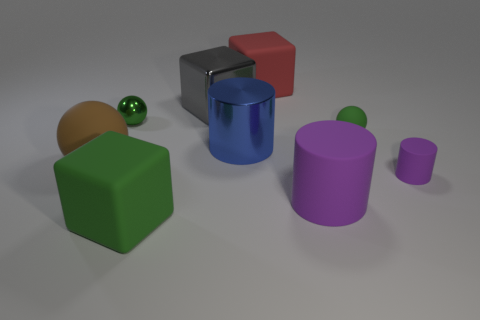There is a brown object that is made of the same material as the large purple thing; what size is it?
Provide a succinct answer. Large. Do the matte sphere that is left of the gray object and the small purple rubber object have the same size?
Offer a terse response. No. Are there more large blocks in front of the large brown rubber object than big cyan objects?
Ensure brevity in your answer.  Yes. Are the large sphere and the green cube made of the same material?
Your answer should be very brief. Yes. What number of objects are cubes in front of the small metallic thing or brown things?
Give a very brief answer. 2. How many other objects are there of the same size as the gray block?
Give a very brief answer. 5. Are there the same number of big green objects right of the big red object and big blue cylinders on the right side of the small purple matte thing?
Make the answer very short. Yes. What is the color of the other matte thing that is the same shape as the red rubber object?
Offer a very short reply. Green. Does the metallic ball behind the blue thing have the same color as the tiny rubber sphere?
Make the answer very short. Yes. There is a brown rubber object that is the same shape as the tiny green metallic thing; what size is it?
Ensure brevity in your answer.  Large. 